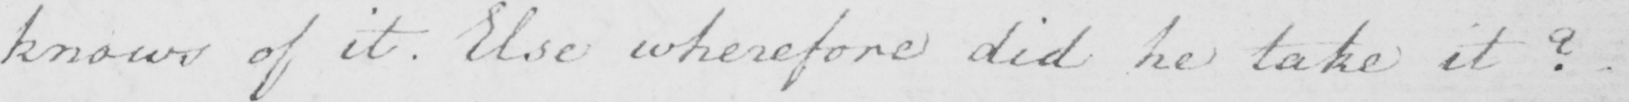Please provide the text content of this handwritten line. knows of it . Else wherefore did he take it ? 